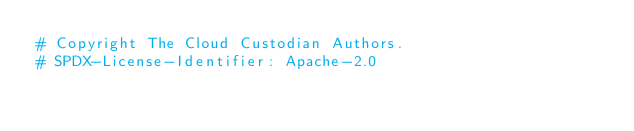<code> <loc_0><loc_0><loc_500><loc_500><_Python_># Copyright The Cloud Custodian Authors.
# SPDX-License-Identifier: Apache-2.0
</code> 